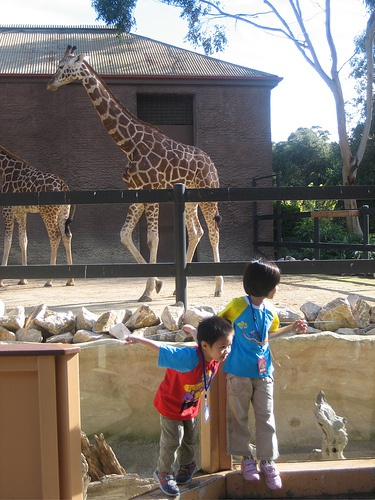Describe the objects in this image and their specific colors. I can see giraffe in white, gray, black, and darkgray tones, people in white, gray, blue, and black tones, people in white, black, gray, brown, and maroon tones, and giraffe in white, gray, and black tones in this image. 